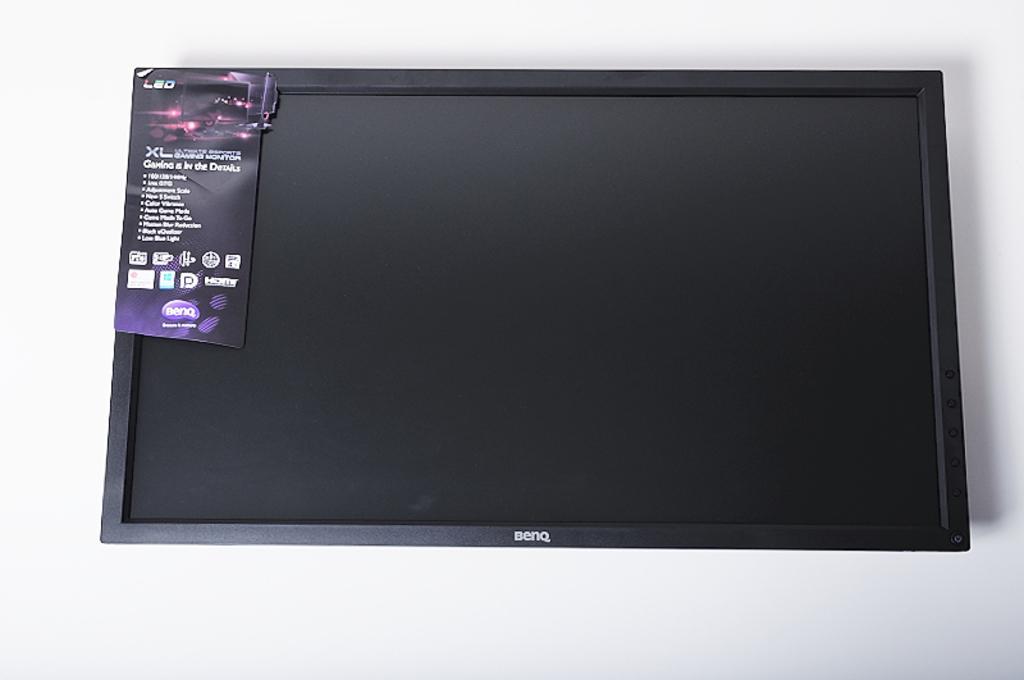Please provide a concise description of this image. This image consists of a TV hanged to the wall. It is in black color on which there is a sticker. In the background, there is a wall in white color. 